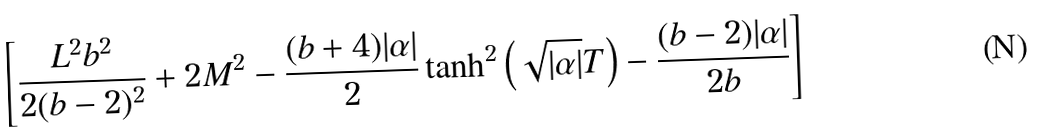<formula> <loc_0><loc_0><loc_500><loc_500>\left [ \frac { L ^ { 2 } b ^ { 2 } } { 2 ( b - 2 ) ^ { 2 } } + 2 M ^ { 2 } - \frac { ( b + 4 ) | \alpha | } { 2 } \tanh ^ { 2 } { \left ( \sqrt { | \alpha | } T \right ) } - \frac { ( b - 2 ) | \alpha | } { 2 b } \right ]</formula> 